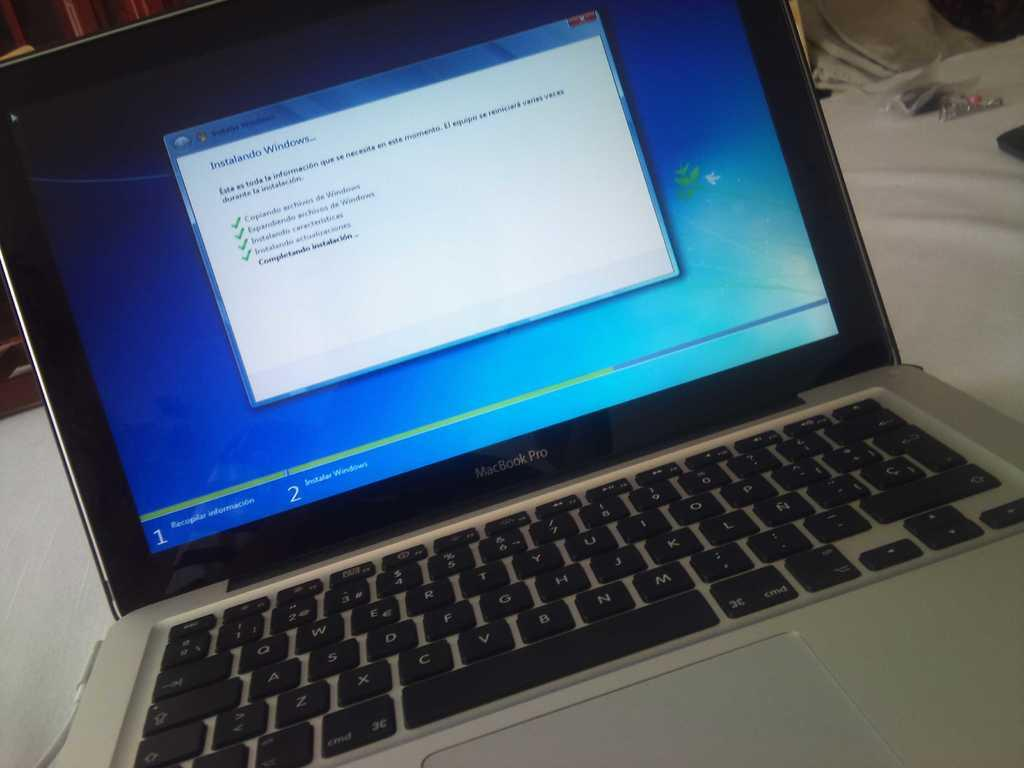What electronic device is visible in the image? There is a laptop in the image. What is the color of the surface on which the laptop is placed? The laptop is on a white surface. Can you describe the background of the image? There are objects in the background of the image, some of which are black and some of which are white. What type of bat can be seen flying around the laptop in the image? There is no bat present in the image; it only features a laptop on a white surface and objects in the background. 